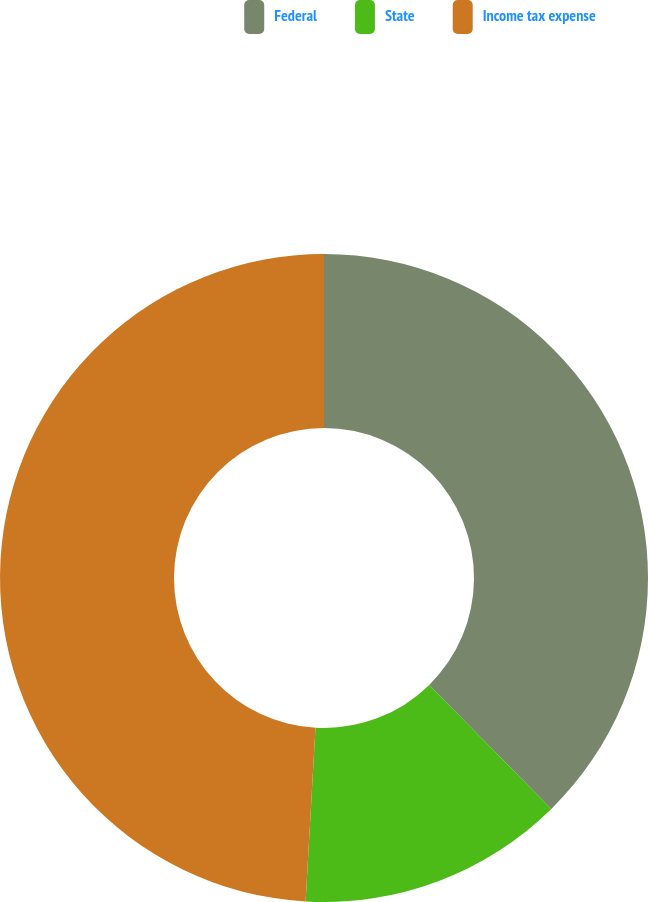Convert chart to OTSL. <chart><loc_0><loc_0><loc_500><loc_500><pie_chart><fcel>Federal<fcel>State<fcel>Income tax expense<nl><fcel>37.62%<fcel>13.28%<fcel>49.09%<nl></chart> 